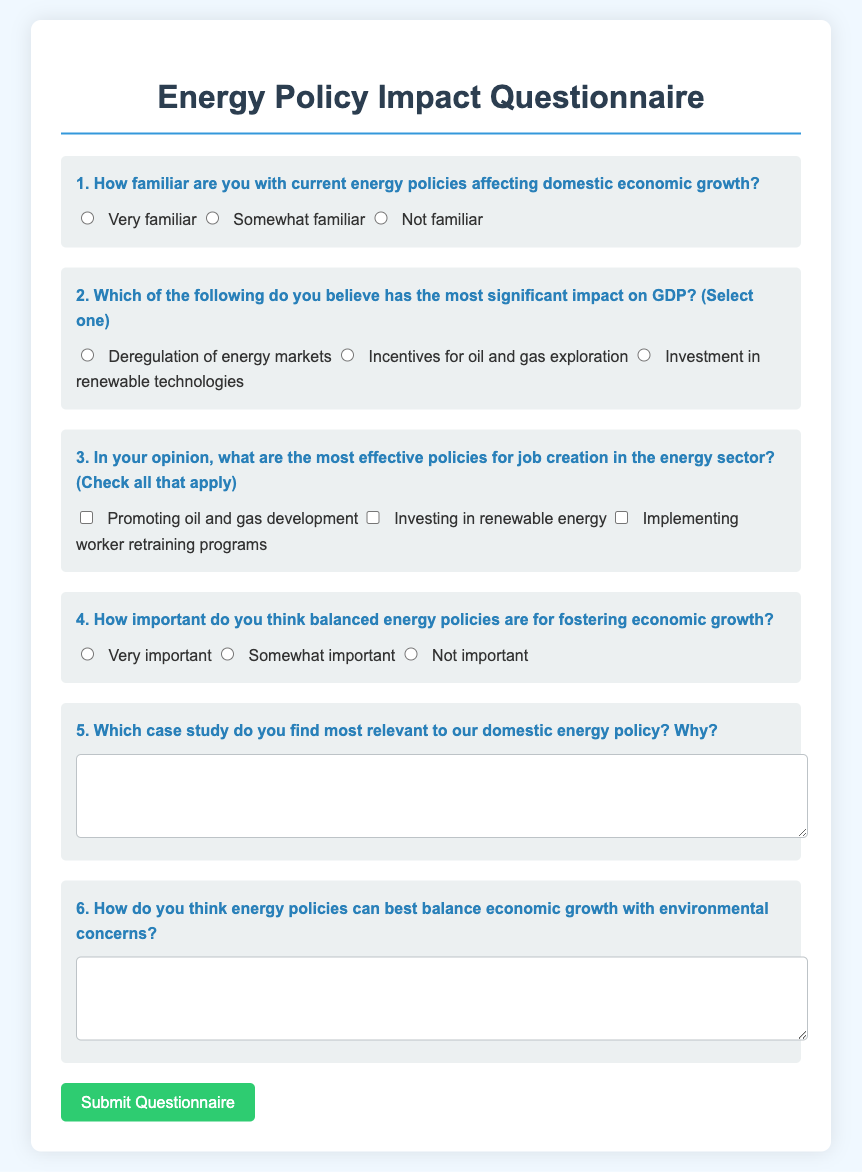What is the title of the questionnaire? The title of the questionnaire is presented prominently at the top of the document.
Answer: Energy Policy Impact Questionnaire How many questions are included in the form? The document contains a total of six questions in the form.
Answer: Six What option indicates a high level of familiarity with energy policies? The document provides multiple choices for familiarity, and one clearly indicates high familiarity.
Answer: Very familiar Which policy is listed as an option for job creation in the energy sector? The document lists various policies for job creation, one of which specifically pertains to oil and gas.
Answer: Promoting oil and gas development What is the maximum number of options that can be selected for question three? The question allows for multiple selections, leading to a specific maximum.
Answer: All that apply What color is used for the submit button? The document specifies a particular color for the submit button that is easily noticeable.
Answer: Green 